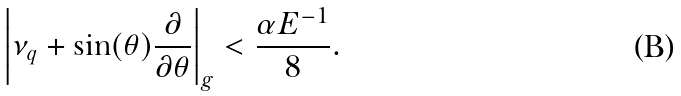Convert formula to latex. <formula><loc_0><loc_0><loc_500><loc_500>\left | \nu _ { q } + \sin ( \theta ) \frac { \partial } { \partial \theta } \right | _ { g } < \frac { \alpha E ^ { - 1 } } { 8 } .</formula> 